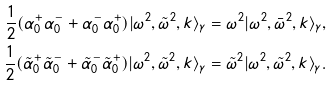Convert formula to latex. <formula><loc_0><loc_0><loc_500><loc_500>\frac { 1 } { 2 } ( \alpha _ { 0 } ^ { + } \alpha _ { 0 } ^ { - } + \alpha _ { 0 } ^ { - } \alpha _ { 0 } ^ { + } ) | \omega ^ { 2 } , { \tilde { \omega } } ^ { 2 } , k \rangle _ { \gamma } = \omega ^ { 2 } | \omega ^ { 2 } , { \bar { \omega } } ^ { 2 } , k \rangle _ { \gamma } , \\ \frac { 1 } { 2 } ( \tilde { \alpha } _ { 0 } ^ { + } \tilde { \alpha } _ { 0 } ^ { - } + \tilde { \alpha } _ { 0 } ^ { - } \tilde { \alpha } _ { 0 } ^ { + } ) | \omega ^ { 2 } , { \tilde { \omega } } ^ { 2 } , k \rangle _ { \gamma } = { \tilde { \omega } } ^ { 2 } | \omega ^ { 2 } , { \tilde { \omega } } ^ { 2 } , k \rangle _ { \gamma } .</formula> 